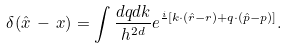<formula> <loc_0><loc_0><loc_500><loc_500>\delta ( { \hat { x } } \, - \, { x } ) = \int \frac { d { q } d { k } } { h ^ { 2 d } } e ^ { \frac { i } { } \left [ { k \cdot } ( { \hat { r } } - r ) + { q \cdot } ( { \hat { p } } - p ) \right ] } .</formula> 